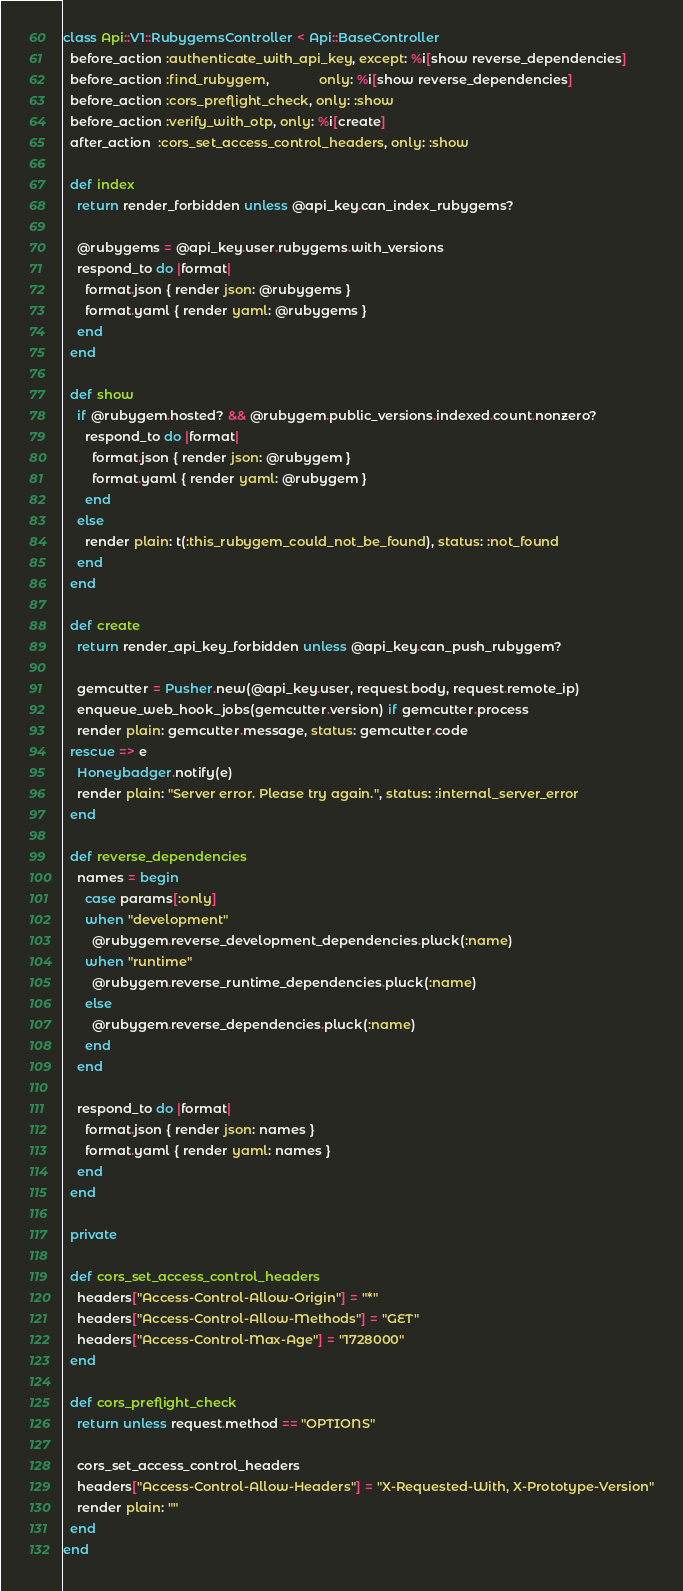<code> <loc_0><loc_0><loc_500><loc_500><_Ruby_>class Api::V1::RubygemsController < Api::BaseController
  before_action :authenticate_with_api_key, except: %i[show reverse_dependencies]
  before_action :find_rubygem,              only: %i[show reverse_dependencies]
  before_action :cors_preflight_check, only: :show
  before_action :verify_with_otp, only: %i[create]
  after_action  :cors_set_access_control_headers, only: :show

  def index
    return render_forbidden unless @api_key.can_index_rubygems?

    @rubygems = @api_key.user.rubygems.with_versions
    respond_to do |format|
      format.json { render json: @rubygems }
      format.yaml { render yaml: @rubygems }
    end
  end

  def show
    if @rubygem.hosted? && @rubygem.public_versions.indexed.count.nonzero?
      respond_to do |format|
        format.json { render json: @rubygem }
        format.yaml { render yaml: @rubygem }
      end
    else
      render plain: t(:this_rubygem_could_not_be_found), status: :not_found
    end
  end

  def create
    return render_api_key_forbidden unless @api_key.can_push_rubygem?

    gemcutter = Pusher.new(@api_key.user, request.body, request.remote_ip)
    enqueue_web_hook_jobs(gemcutter.version) if gemcutter.process
    render plain: gemcutter.message, status: gemcutter.code
  rescue => e
    Honeybadger.notify(e)
    render plain: "Server error. Please try again.", status: :internal_server_error
  end

  def reverse_dependencies
    names = begin
      case params[:only]
      when "development"
        @rubygem.reverse_development_dependencies.pluck(:name)
      when "runtime"
        @rubygem.reverse_runtime_dependencies.pluck(:name)
      else
        @rubygem.reverse_dependencies.pluck(:name)
      end
    end

    respond_to do |format|
      format.json { render json: names }
      format.yaml { render yaml: names }
    end
  end

  private

  def cors_set_access_control_headers
    headers["Access-Control-Allow-Origin"] = "*"
    headers["Access-Control-Allow-Methods"] = "GET"
    headers["Access-Control-Max-Age"] = "1728000"
  end

  def cors_preflight_check
    return unless request.method == "OPTIONS"

    cors_set_access_control_headers
    headers["Access-Control-Allow-Headers"] = "X-Requested-With, X-Prototype-Version"
    render plain: ""
  end
end
</code> 